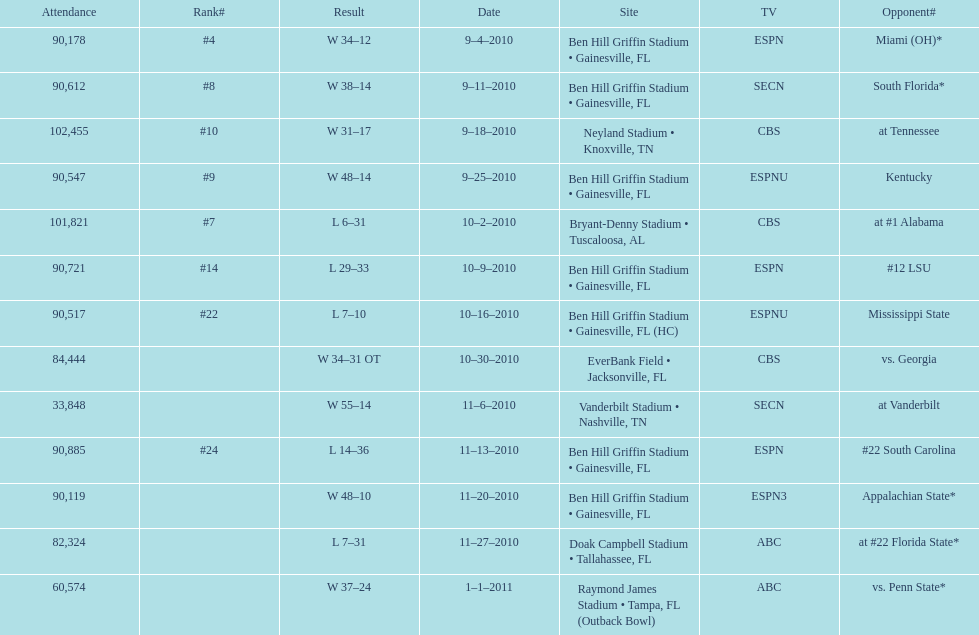What tv network showed the largest number of games during the 2010/2011 season? ESPN. 